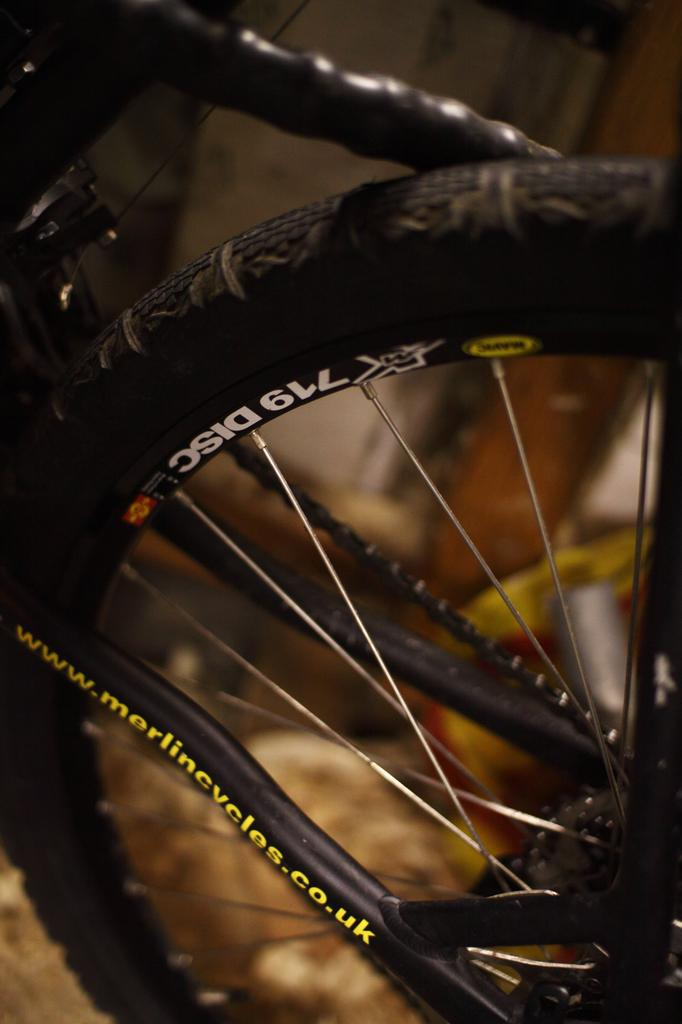What object is the main subject of the image? The main subject of the image is a bicycle wheel. Are there any words or letters on the bicycle wheel? Yes, there is text on the bicycle wheel. Can you describe the background of the image? The background of the image is blurred. What type of authority figure can be seen in the image? There is no authority figure present in the image; it features a bicycle wheel with text on it. What kind of wire is connected to the bicycle wheel in the image? There is no wire connected to the bicycle wheel in the image. 